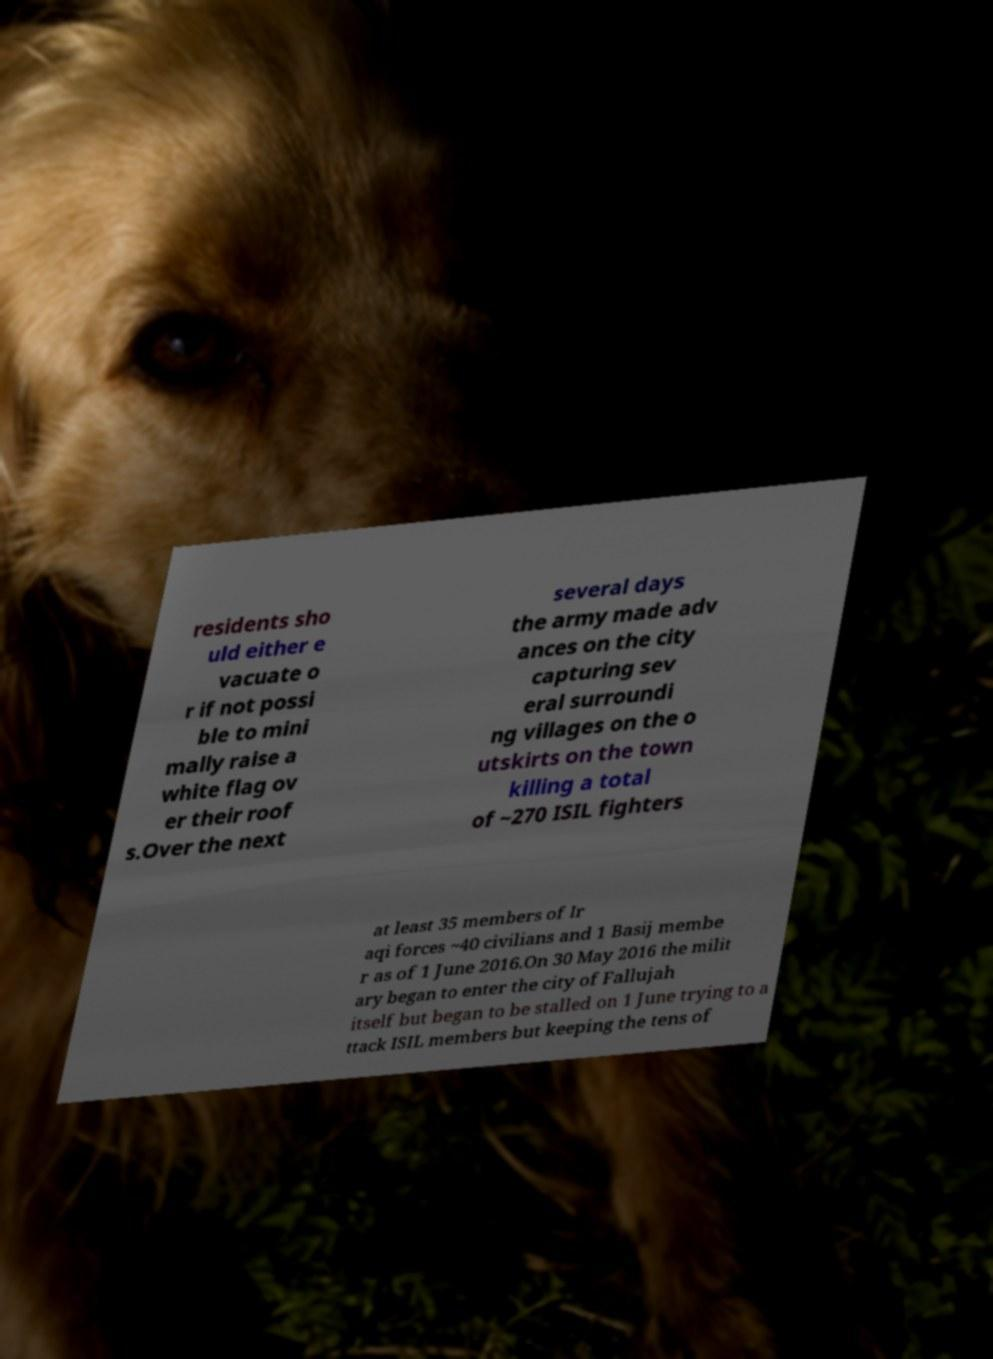There's text embedded in this image that I need extracted. Can you transcribe it verbatim? residents sho uld either e vacuate o r if not possi ble to mini mally raise a white flag ov er their roof s.Over the next several days the army made adv ances on the city capturing sev eral surroundi ng villages on the o utskirts on the town killing a total of ~270 ISIL fighters at least 35 members of Ir aqi forces ~40 civilians and 1 Basij membe r as of 1 June 2016.On 30 May 2016 the milit ary began to enter the city of Fallujah itself but began to be stalled on 1 June trying to a ttack ISIL members but keeping the tens of 